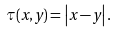<formula> <loc_0><loc_0><loc_500><loc_500>\tau ( x , y ) = \left | x - y \right | .</formula> 